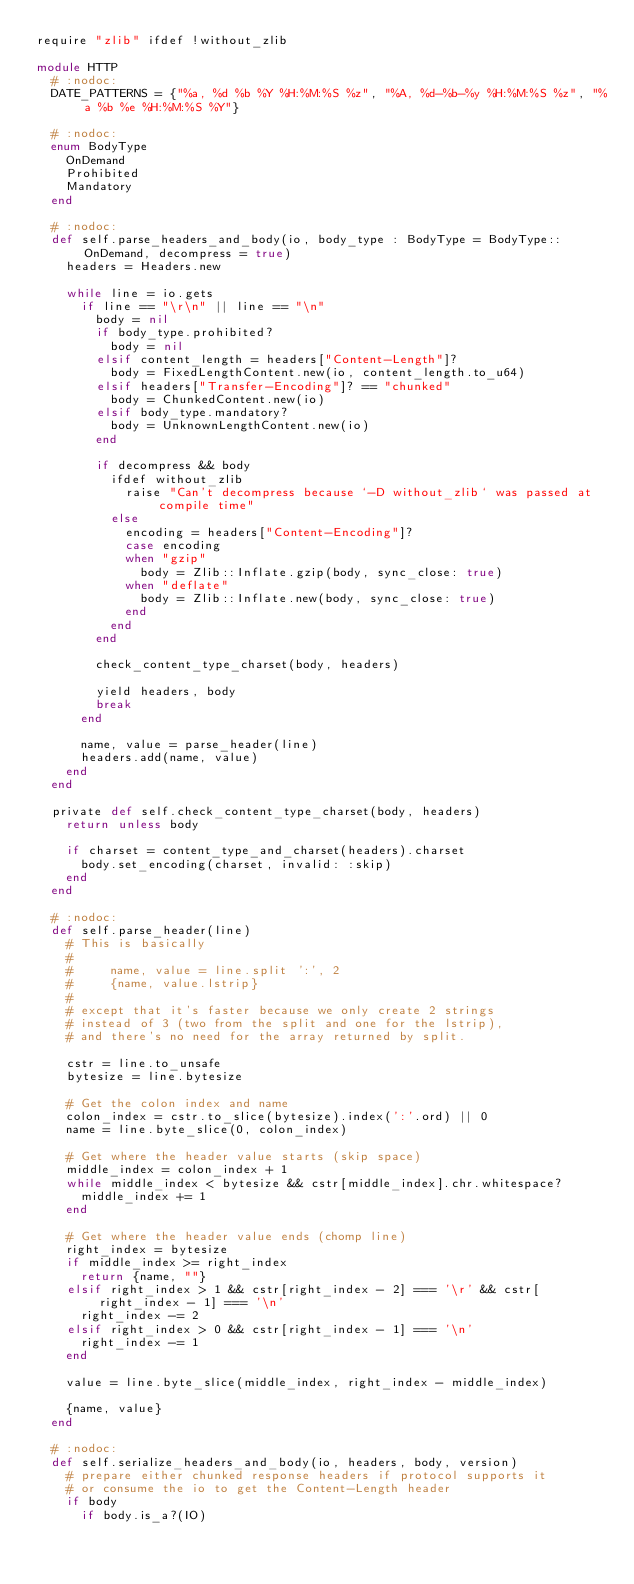Convert code to text. <code><loc_0><loc_0><loc_500><loc_500><_Crystal_>require "zlib" ifdef !without_zlib

module HTTP
  # :nodoc:
  DATE_PATTERNS = {"%a, %d %b %Y %H:%M:%S %z", "%A, %d-%b-%y %H:%M:%S %z", "%a %b %e %H:%M:%S %Y"}

  # :nodoc:
  enum BodyType
    OnDemand
    Prohibited
    Mandatory
  end

  # :nodoc:
  def self.parse_headers_and_body(io, body_type : BodyType = BodyType::OnDemand, decompress = true)
    headers = Headers.new

    while line = io.gets
      if line == "\r\n" || line == "\n"
        body = nil
        if body_type.prohibited?
          body = nil
        elsif content_length = headers["Content-Length"]?
          body = FixedLengthContent.new(io, content_length.to_u64)
        elsif headers["Transfer-Encoding"]? == "chunked"
          body = ChunkedContent.new(io)
        elsif body_type.mandatory?
          body = UnknownLengthContent.new(io)
        end

        if decompress && body
          ifdef without_zlib
            raise "Can't decompress because `-D without_zlib` was passed at compile time"
          else
            encoding = headers["Content-Encoding"]?
            case encoding
            when "gzip"
              body = Zlib::Inflate.gzip(body, sync_close: true)
            when "deflate"
              body = Zlib::Inflate.new(body, sync_close: true)
            end
          end
        end

        check_content_type_charset(body, headers)

        yield headers, body
        break
      end

      name, value = parse_header(line)
      headers.add(name, value)
    end
  end

  private def self.check_content_type_charset(body, headers)
    return unless body

    if charset = content_type_and_charset(headers).charset
      body.set_encoding(charset, invalid: :skip)
    end
  end

  # :nodoc:
  def self.parse_header(line)
    # This is basically
    #
    #     name, value = line.split ':', 2
    #     {name, value.lstrip}
    #
    # except that it's faster because we only create 2 strings
    # instead of 3 (two from the split and one for the lstrip),
    # and there's no need for the array returned by split.

    cstr = line.to_unsafe
    bytesize = line.bytesize

    # Get the colon index and name
    colon_index = cstr.to_slice(bytesize).index(':'.ord) || 0
    name = line.byte_slice(0, colon_index)

    # Get where the header value starts (skip space)
    middle_index = colon_index + 1
    while middle_index < bytesize && cstr[middle_index].chr.whitespace?
      middle_index += 1
    end

    # Get where the header value ends (chomp line)
    right_index = bytesize
    if middle_index >= right_index
      return {name, ""}
    elsif right_index > 1 && cstr[right_index - 2] === '\r' && cstr[right_index - 1] === '\n'
      right_index -= 2
    elsif right_index > 0 && cstr[right_index - 1] === '\n'
      right_index -= 1
    end

    value = line.byte_slice(middle_index, right_index - middle_index)

    {name, value}
  end

  # :nodoc:
  def self.serialize_headers_and_body(io, headers, body, version)
    # prepare either chunked response headers if protocol supports it
    # or consume the io to get the Content-Length header
    if body
      if body.is_a?(IO)</code> 